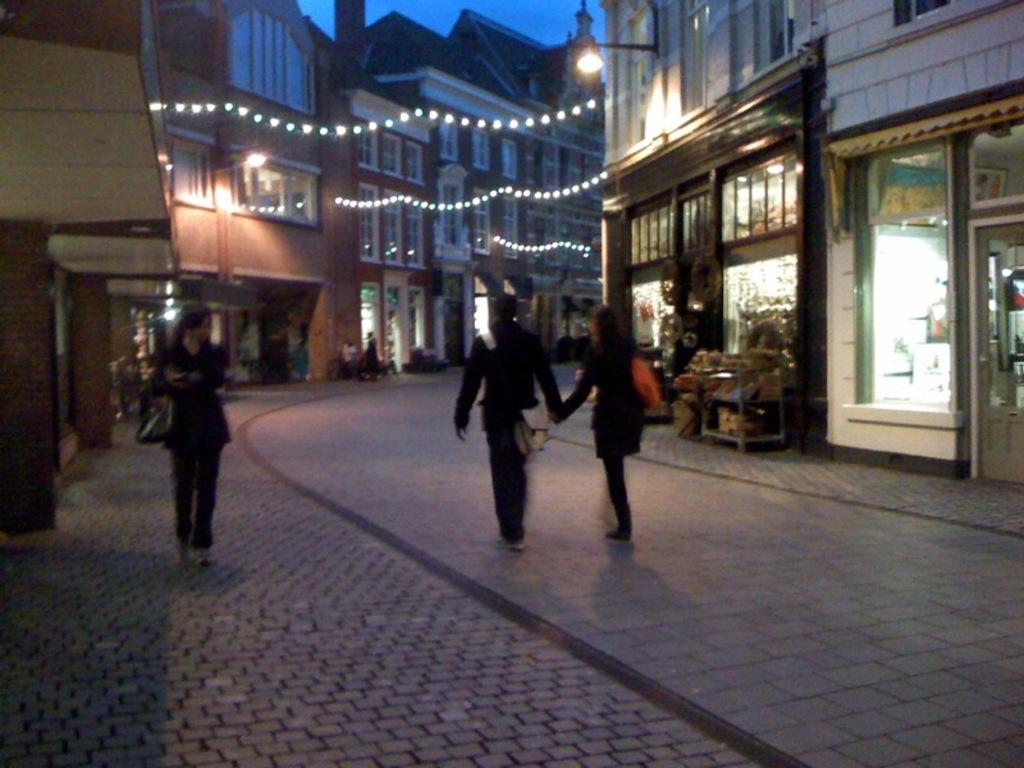How many people are in the image? There are three persons in the image. What else can be seen in the image besides the people? There are buildings, lights, windows, pillars, and frames in the image. What is visible in the background of the image? The sky is visible in the background of the image. How many dogs are sleeping on the beds in the image? There are no dogs or beds present in the image. 